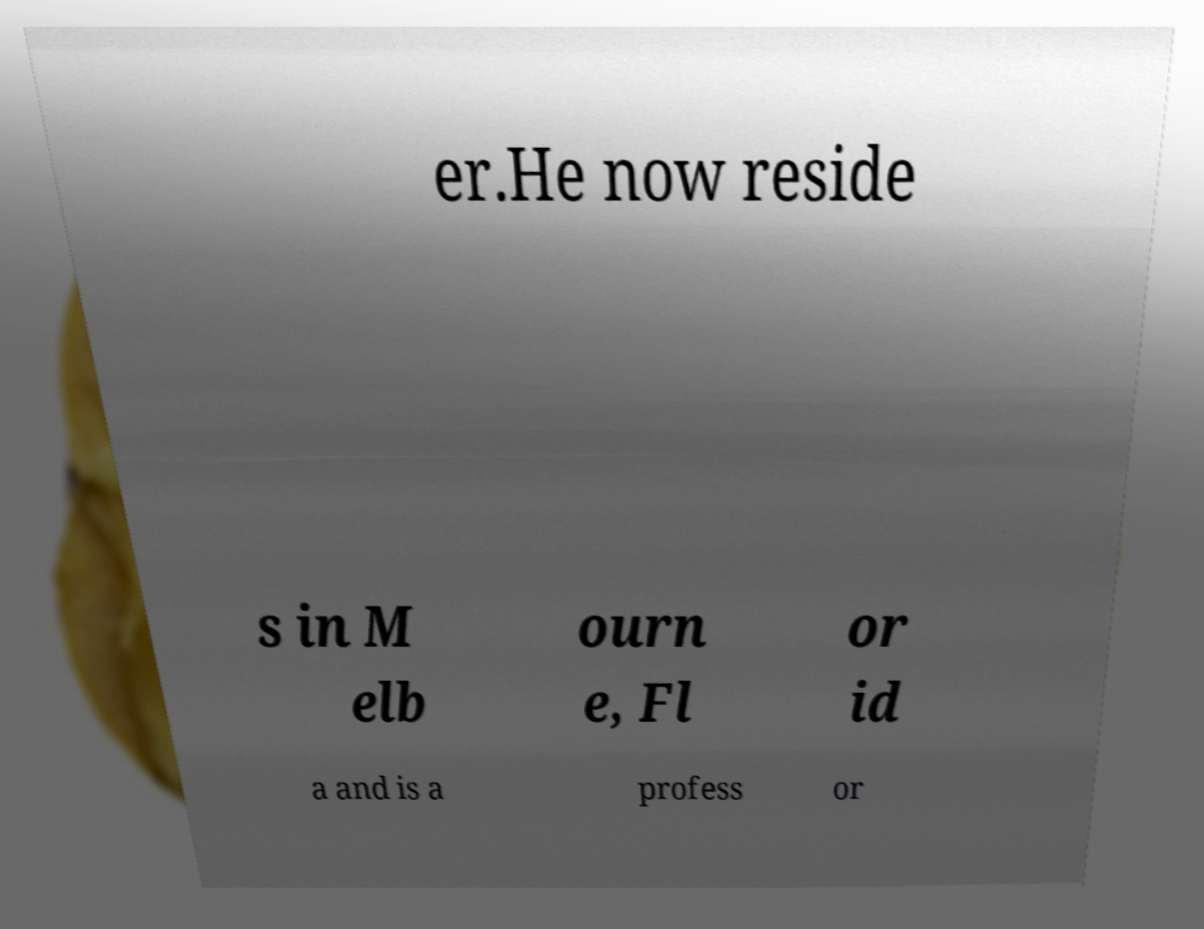Can you read and provide the text displayed in the image?This photo seems to have some interesting text. Can you extract and type it out for me? er.He now reside s in M elb ourn e, Fl or id a and is a profess or 